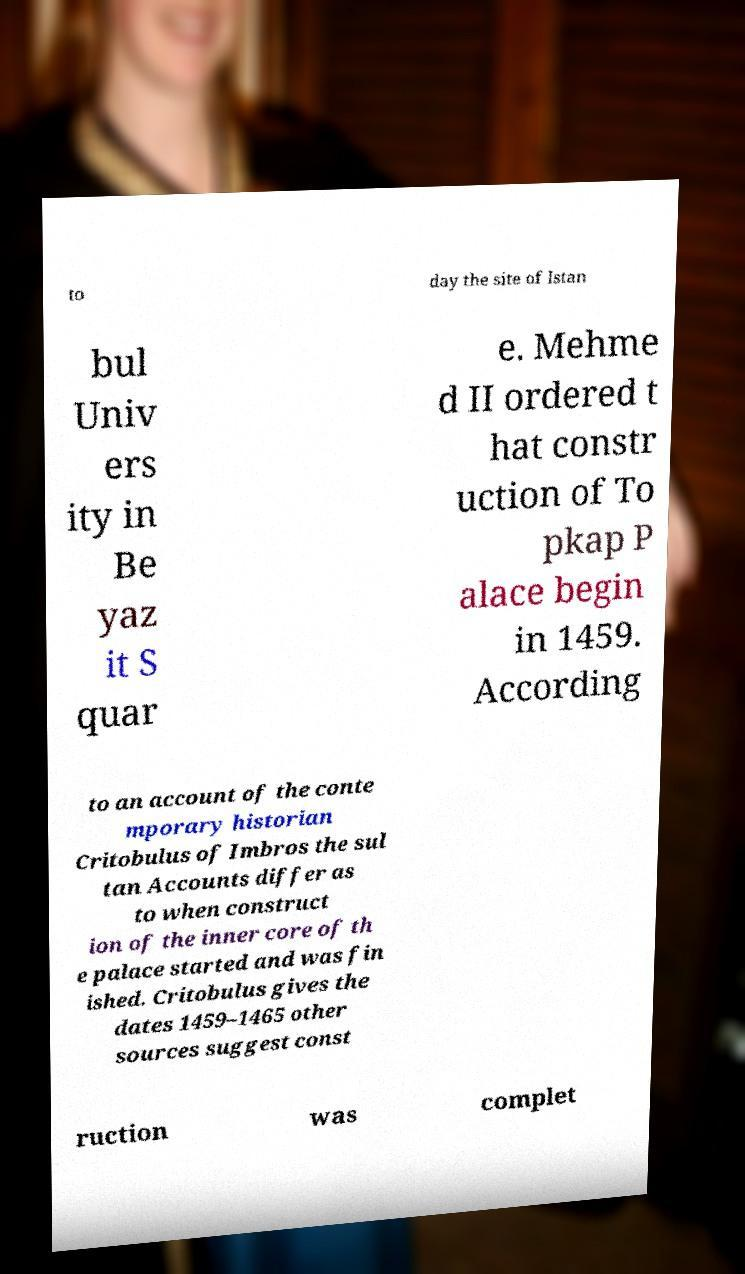For documentation purposes, I need the text within this image transcribed. Could you provide that? to day the site of Istan bul Univ ers ity in Be yaz it S quar e. Mehme d II ordered t hat constr uction of To pkap P alace begin in 1459. According to an account of the conte mporary historian Critobulus of Imbros the sul tan Accounts differ as to when construct ion of the inner core of th e palace started and was fin ished. Critobulus gives the dates 1459–1465 other sources suggest const ruction was complet 